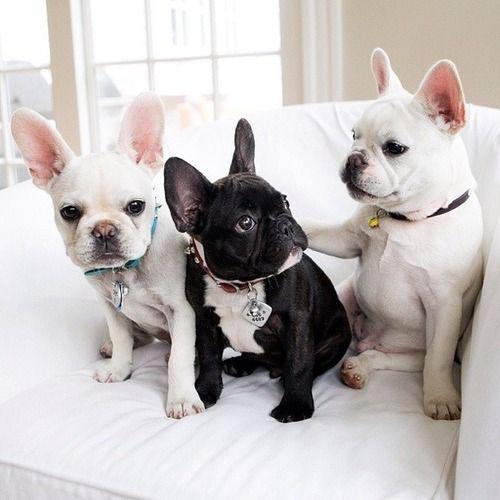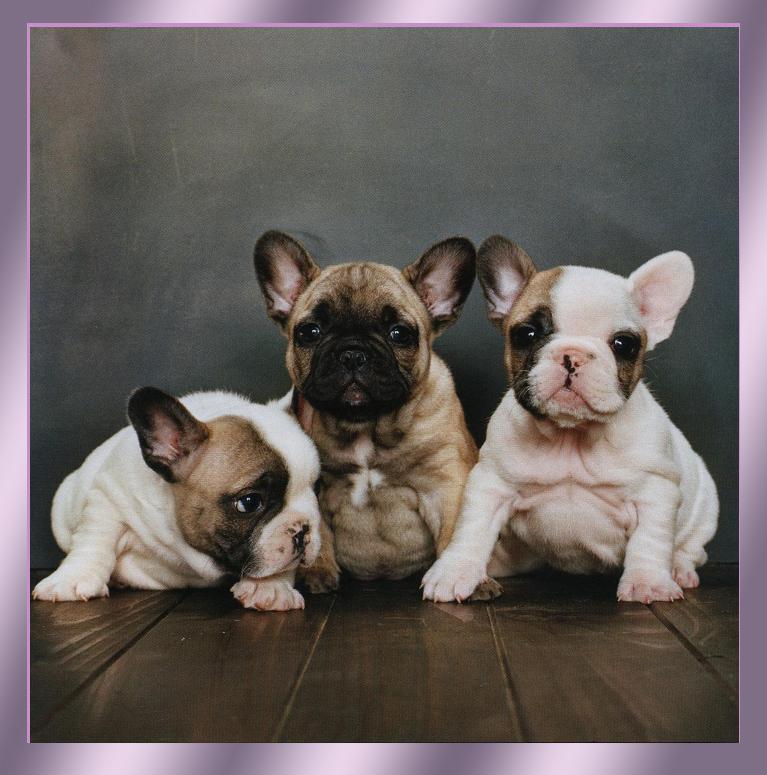The first image is the image on the left, the second image is the image on the right. Given the left and right images, does the statement "In one of the images, the dogs are standing on the pavement outside." hold true? Answer yes or no. No. The first image is the image on the left, the second image is the image on the right. Evaluate the accuracy of this statement regarding the images: "An image shows a horizontal row of three similarly colored dogs in similar poses.". Is it true? Answer yes or no. No. 